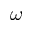Convert formula to latex. <formula><loc_0><loc_0><loc_500><loc_500>\omega</formula> 